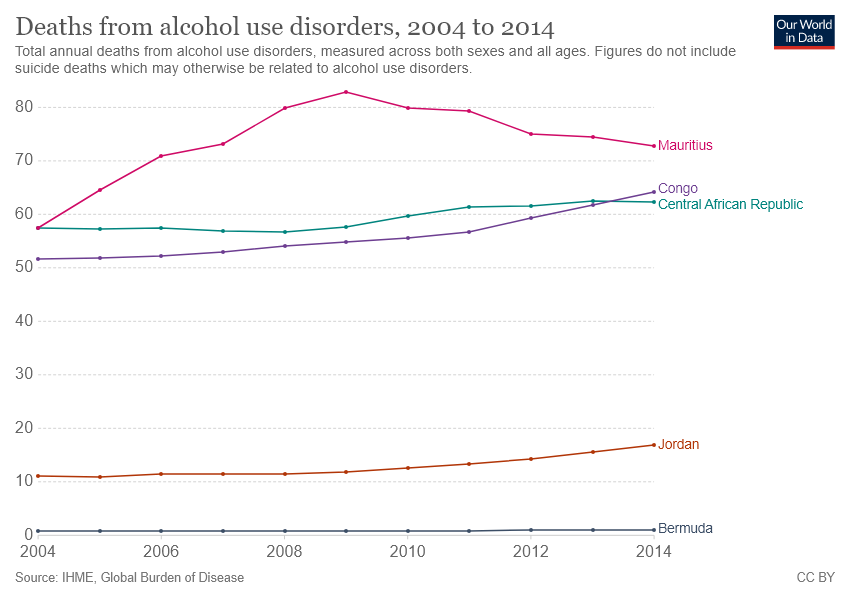Specify some key components in this picture. The alcohol use disorders of Jordan and Congo differ in terms of their severity and symptoms. There are five colors visible in the bar graph. 